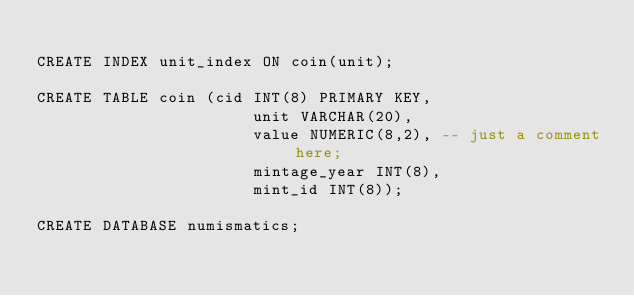<code> <loc_0><loc_0><loc_500><loc_500><_SQL_>
CREATE INDEX unit_index ON coin(unit);

CREATE TABLE coin (cid INT(8) PRIMARY KEY,
                       unit VARCHAR(20),
                       value NUMERIC(8,2), -- just a comment here;
                       mintage_year INT(8),
                       mint_id INT(8));

CREATE DATABASE numismatics;  
</code> 